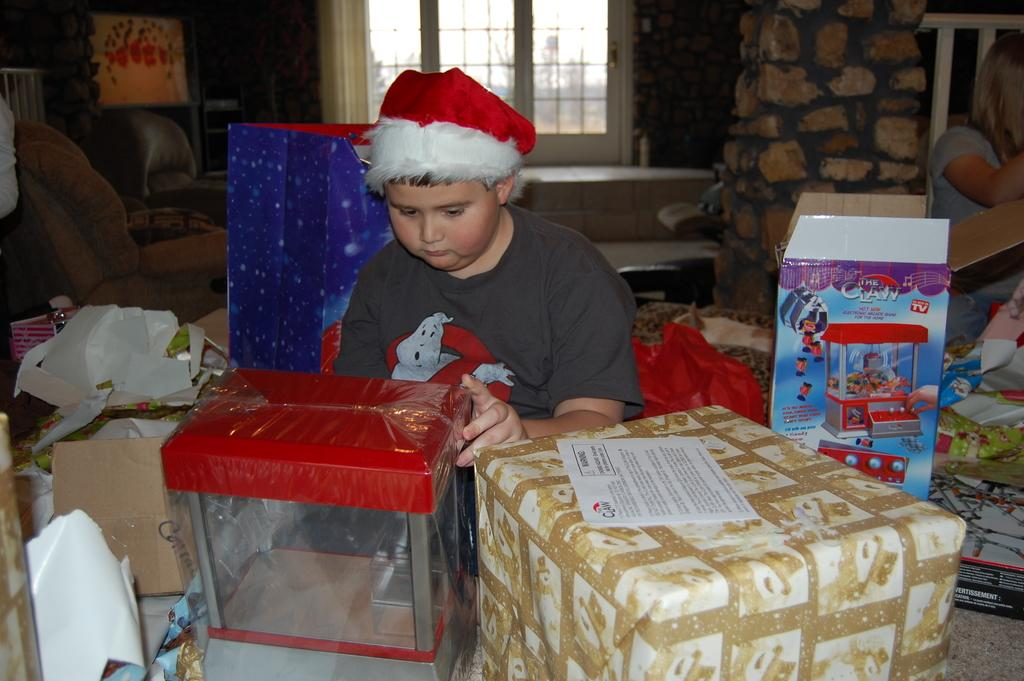How many people are in the image? There are two people in the image. What type of objects can be seen in the image? Cardboard boxes, papers, boxes, chairs, windows, and a wall are present in the image. Can you describe the additional objects in the image? Unfortunately, the provided facts do not specify the nature of the additional objects. What might be the purpose of the chairs in the image? The chairs in the image might be used for sitting or as a temporary storage solution. How many pies are being held by the boy in the image? There is no boy present in the image, and therefore no pies can be held by a boy. What type of tail is visible on the pies in the image? There are no pies or tails present in the image. 